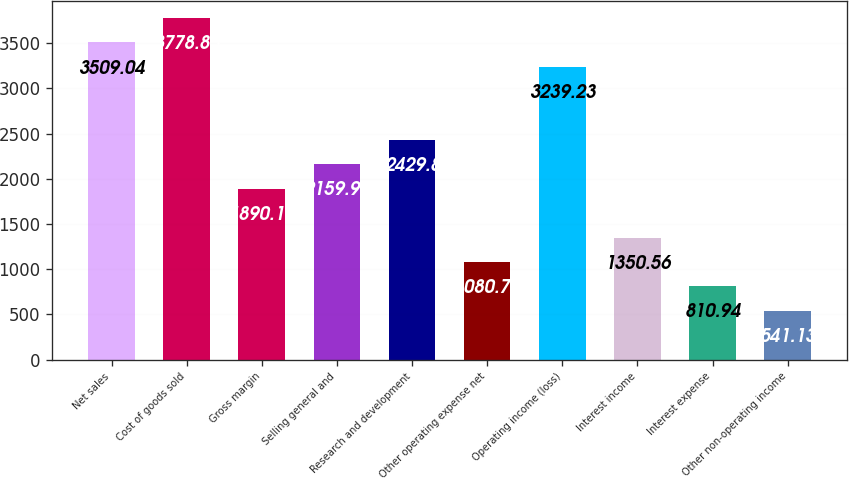<chart> <loc_0><loc_0><loc_500><loc_500><bar_chart><fcel>Net sales<fcel>Cost of goods sold<fcel>Gross margin<fcel>Selling general and<fcel>Research and development<fcel>Other operating expense net<fcel>Operating income (loss)<fcel>Interest income<fcel>Interest expense<fcel>Other non-operating income<nl><fcel>3509.04<fcel>3778.85<fcel>1890.18<fcel>2159.99<fcel>2429.8<fcel>1080.75<fcel>3239.23<fcel>1350.56<fcel>810.94<fcel>541.13<nl></chart> 